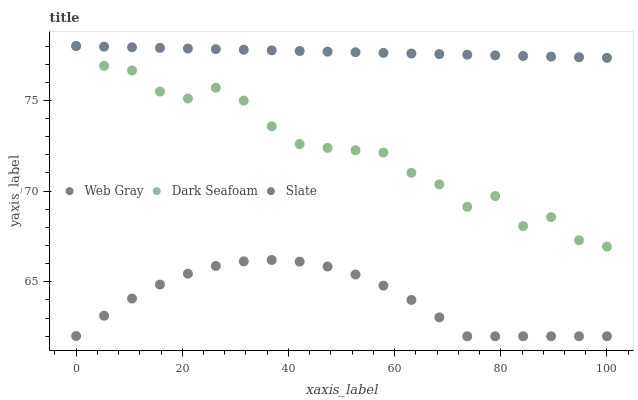Does Web Gray have the minimum area under the curve?
Answer yes or no. Yes. Does Slate have the maximum area under the curve?
Answer yes or no. Yes. Does Slate have the minimum area under the curve?
Answer yes or no. No. Does Web Gray have the maximum area under the curve?
Answer yes or no. No. Is Slate the smoothest?
Answer yes or no. Yes. Is Dark Seafoam the roughest?
Answer yes or no. Yes. Is Web Gray the smoothest?
Answer yes or no. No. Is Web Gray the roughest?
Answer yes or no. No. Does Web Gray have the lowest value?
Answer yes or no. Yes. Does Slate have the lowest value?
Answer yes or no. No. Does Slate have the highest value?
Answer yes or no. Yes. Does Web Gray have the highest value?
Answer yes or no. No. Is Web Gray less than Dark Seafoam?
Answer yes or no. Yes. Is Slate greater than Web Gray?
Answer yes or no. Yes. Does Slate intersect Dark Seafoam?
Answer yes or no. Yes. Is Slate less than Dark Seafoam?
Answer yes or no. No. Is Slate greater than Dark Seafoam?
Answer yes or no. No. Does Web Gray intersect Dark Seafoam?
Answer yes or no. No. 